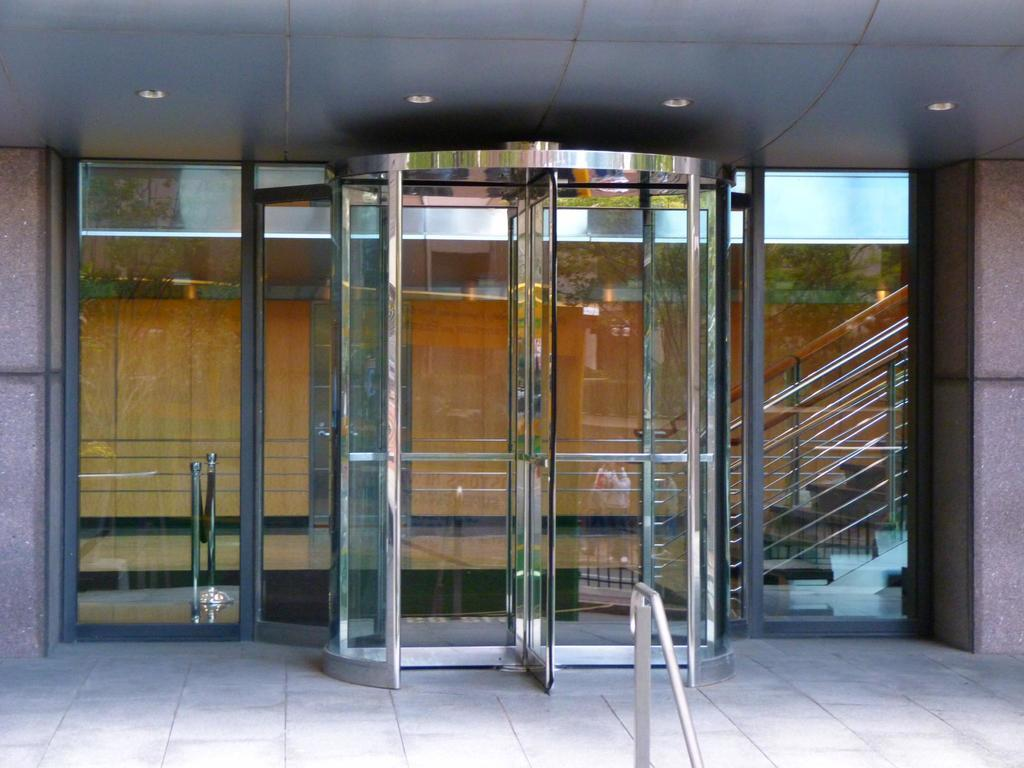What type of structure is present in the image? There is a building in the image. What feature of the building is mentioned in the facts? The building has doors, specifically revolving doors. Are there any additional details about the building's interior? Yes, there are lights attached to the ceiling in the image. What type of blade can be seen attached to the engine in the image? There is no engine or blade present in the image; it features a building with revolving doors and lights attached to the ceiling. 